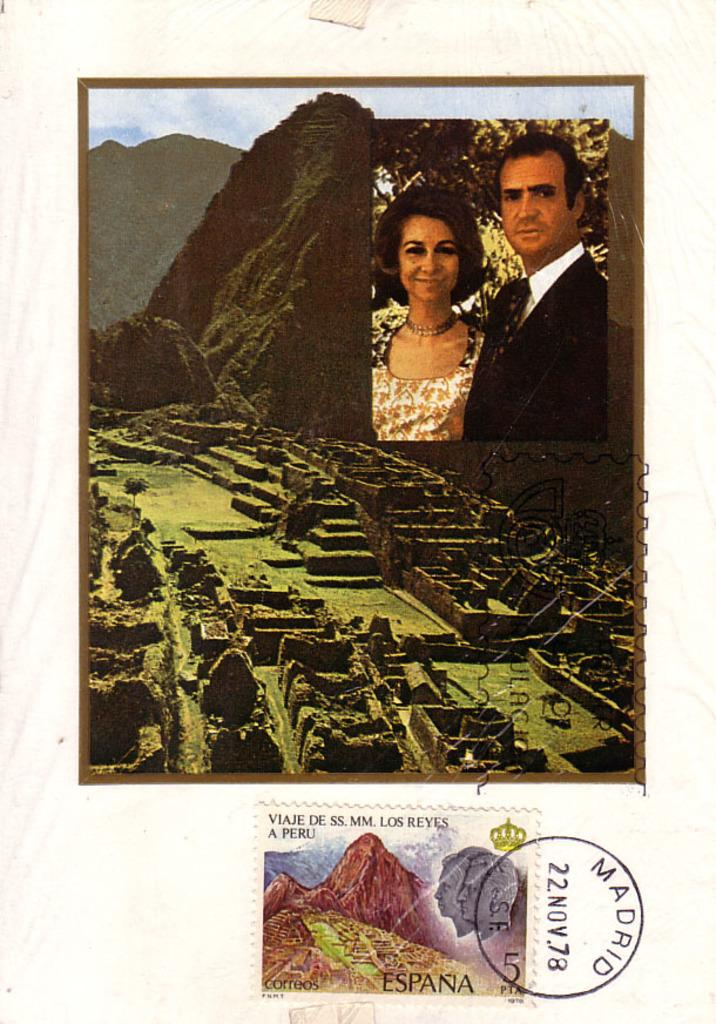What type of scene is depicted in the image? The image contains a college scene. How many people are present in the image? There are two people in the image. What can be seen in the background of the image? There are mountains in the background of the image. What type of structures are visible in the image? There are walls in the image. What part of the natural environment is visible in the image? The ground and the sky are visible in the image. Can you describe the postal-stamp in the image? There is a postal-stamp attached to a cream-colored surface in the image. What time does the clock in the image show? There is no clock present in the image. What type of doctor is attending to the people in the image? There are no doctors or medical situations depicted in the image. 